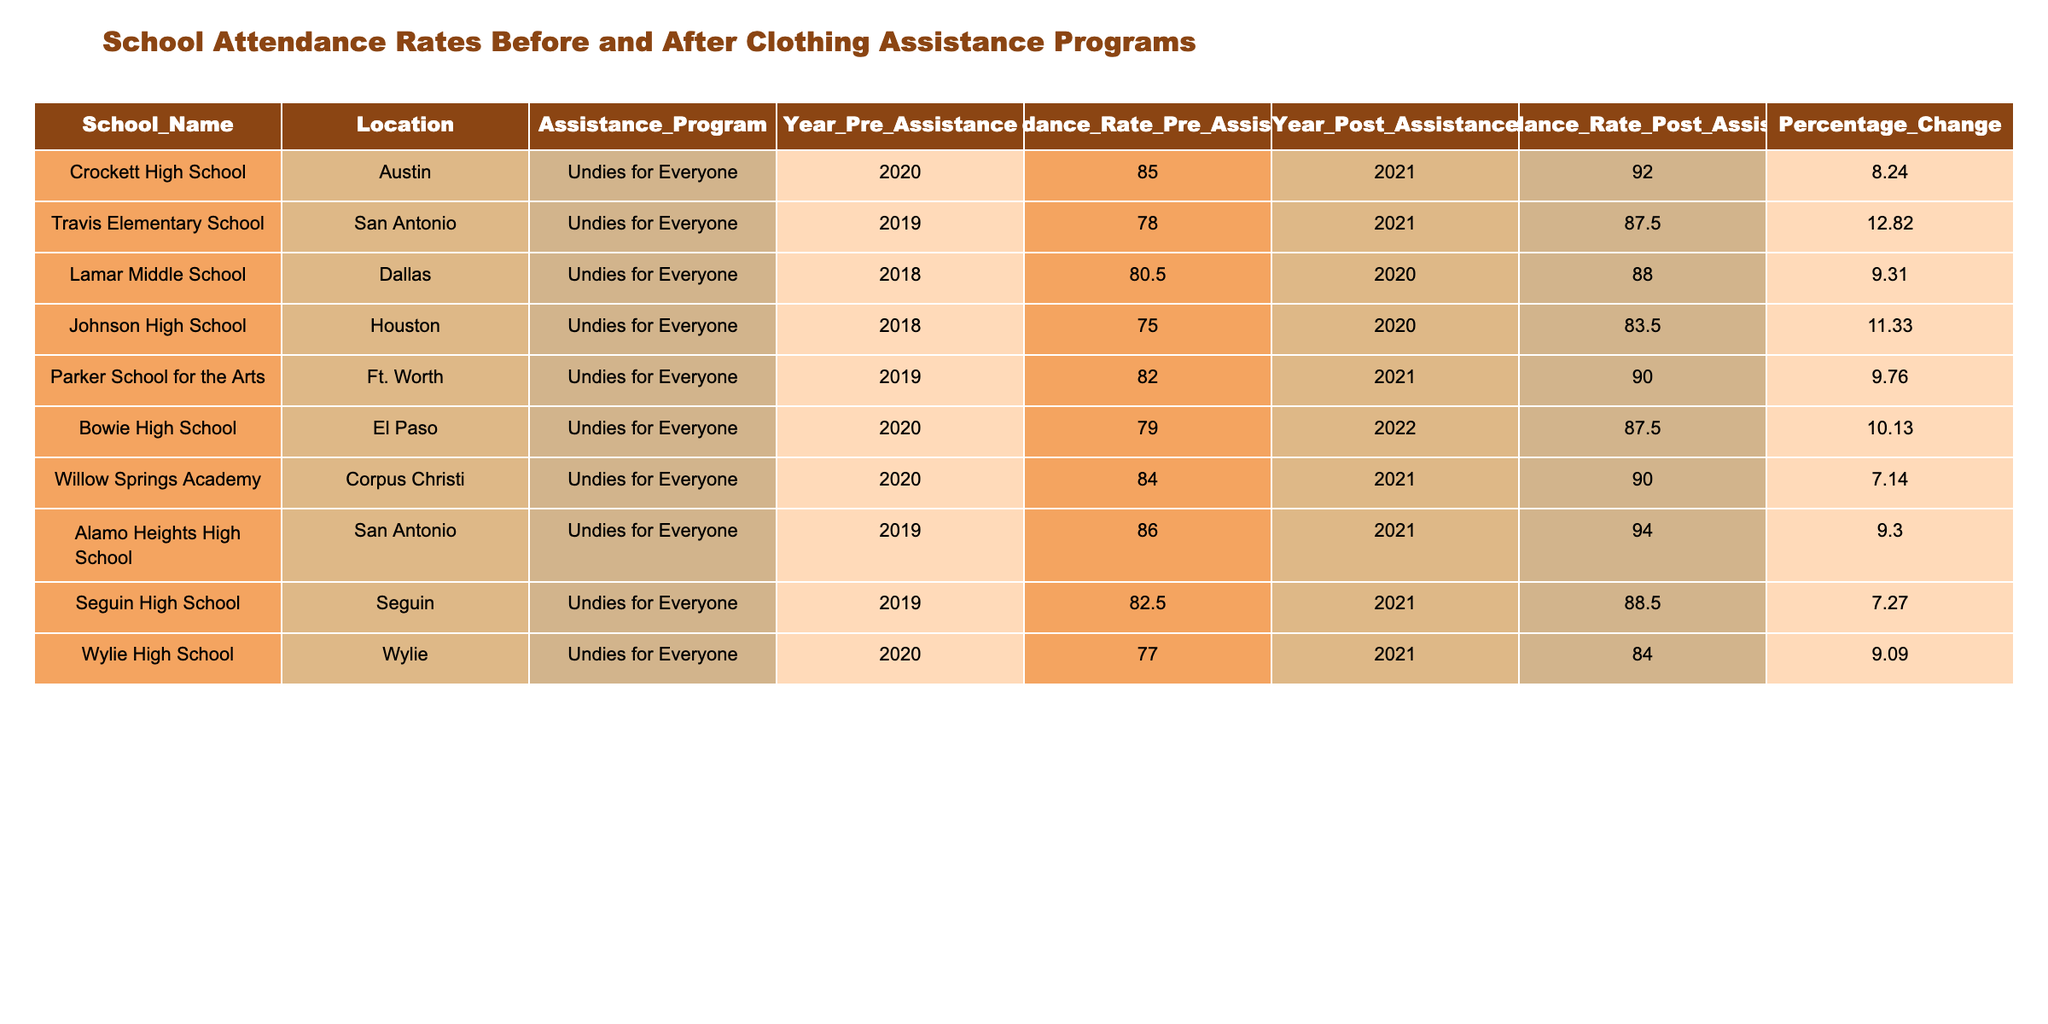What was the attendance rate at Crockett High School before assistance? The table indicates that the attendance rate at Crockett High School before assistance was 85.0 in the year 2020.
Answer: 85.0 What is the percentage change in attendance rate for Parker School for the Arts? According to the table, the percentage change in attendance rate for Parker School for the Arts is 9.76.
Answer: 9.76 Which school had the highest attendance rate post-assistance? The table shows that Alamo Heights High School had the highest attendance rate post-assistance at 94.0 in the year 2021.
Answer: 94.0 Did any school experience a percentage change greater than 12%? Yes, Travis Elementary School experienced a percentage change of 12.82, which is greater than 12%.
Answer: Yes What is the average attendance rate before assistance across all schools? To find the average, add up all the attendance rates before assistance (85.0 + 78.0 + 80.5 + 75.0 + 82.0 + 79.0 + 84.0 + 86.0 + 82.5 + 77.0 = 814.0) and divide by the number of schools (10). The average is 814.0 / 10 = 81.4.
Answer: 81.4 Which school had the second highest attendance rate after assistance? The table shows that Crockett High School had an attendance rate of 92.0 and Parker School for the Arts had 90.0, so the second highest attendance rate after assistance is for Crockett High School.
Answer: Crockett High School What is the overall percentage change in attendance rates for all schools combined? Calculate the sum of the percentage changes (8.24 + 12.82 + 9.31 + 11.33 + 9.76 + 10.13 + 7.14 + 9.30 + 7.27 + 9.09 = 88.45) and divide by the number of schools (10). The overall average percentage change is 88.45 / 10 = 8.845.
Answer: 8.85 Is there a school where the attendance rate post-assistance declined? No, all schools reported an increase in attendance rates after assistance.
Answer: No How many schools had an attendance rate above 80% after assistance? By looking at the table, six schools: Crockett High School (92.0), Travis Elementary School (87.5), Lamar Middle School (88.0), Parker School for the Arts (90.0), Alamo Heights High School (94.0), and Willow Springs Academy (90.0) had an attendance rate above 80% post-assistance.
Answer: 6 What year did Johnson High School receive assistance? The table indicates that Johnson High School received assistance in the year 2018.
Answer: 2018 